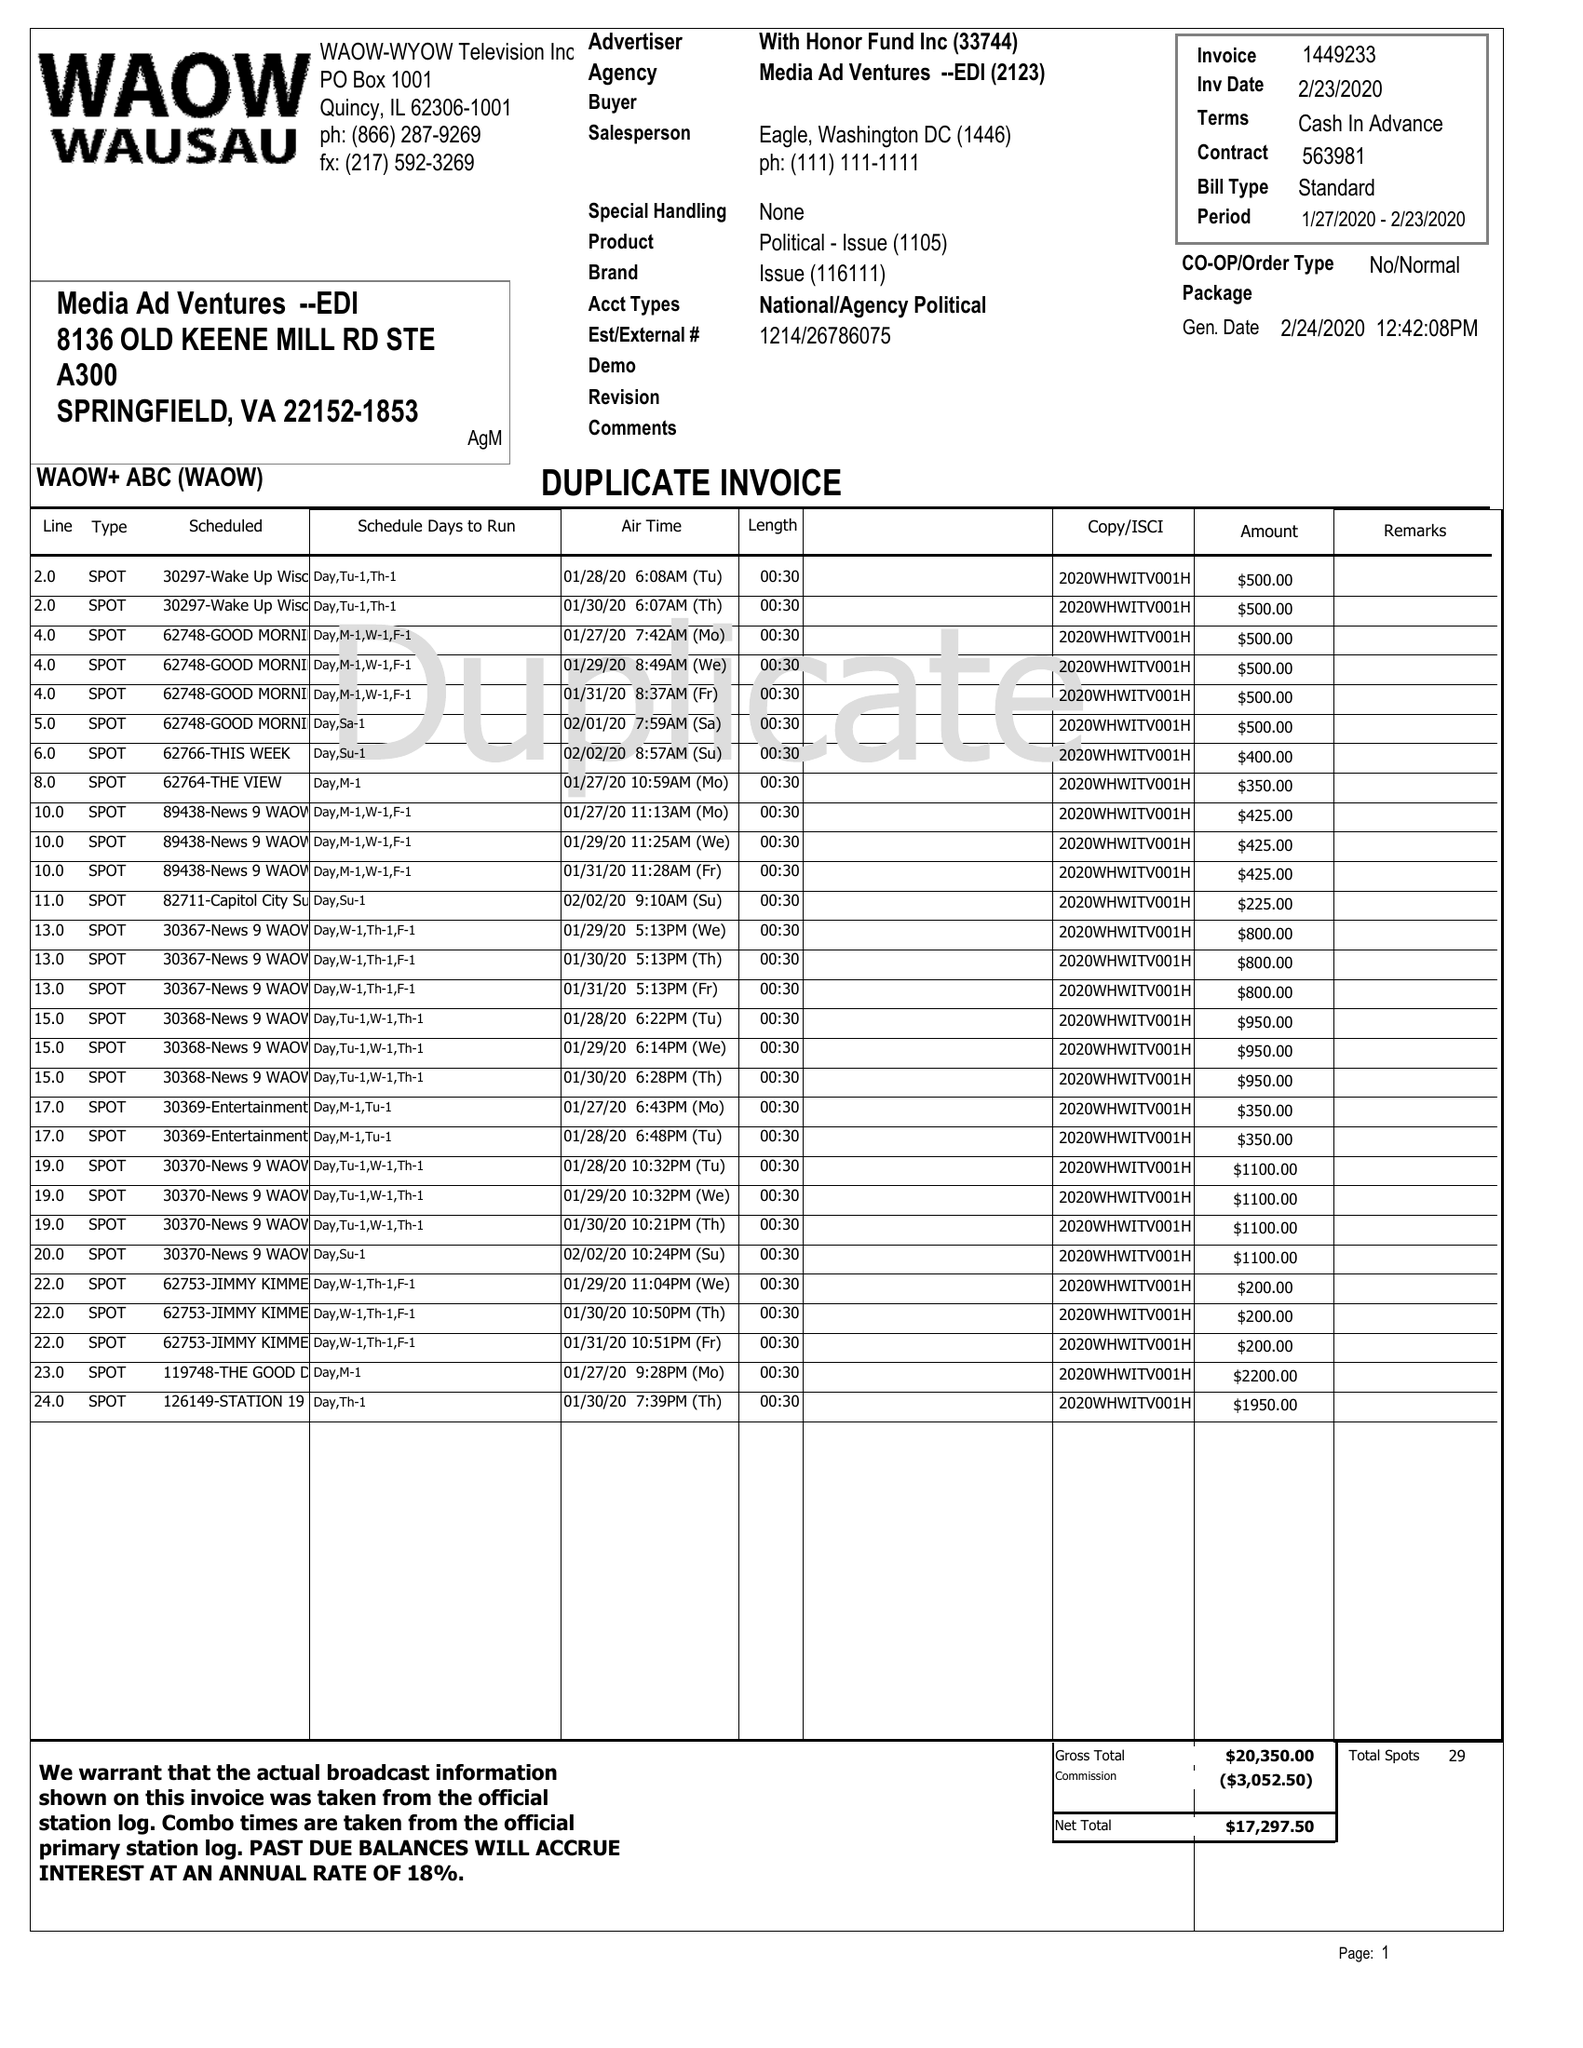What is the value for the advertiser?
Answer the question using a single word or phrase. WITH HONOR FUND INC 